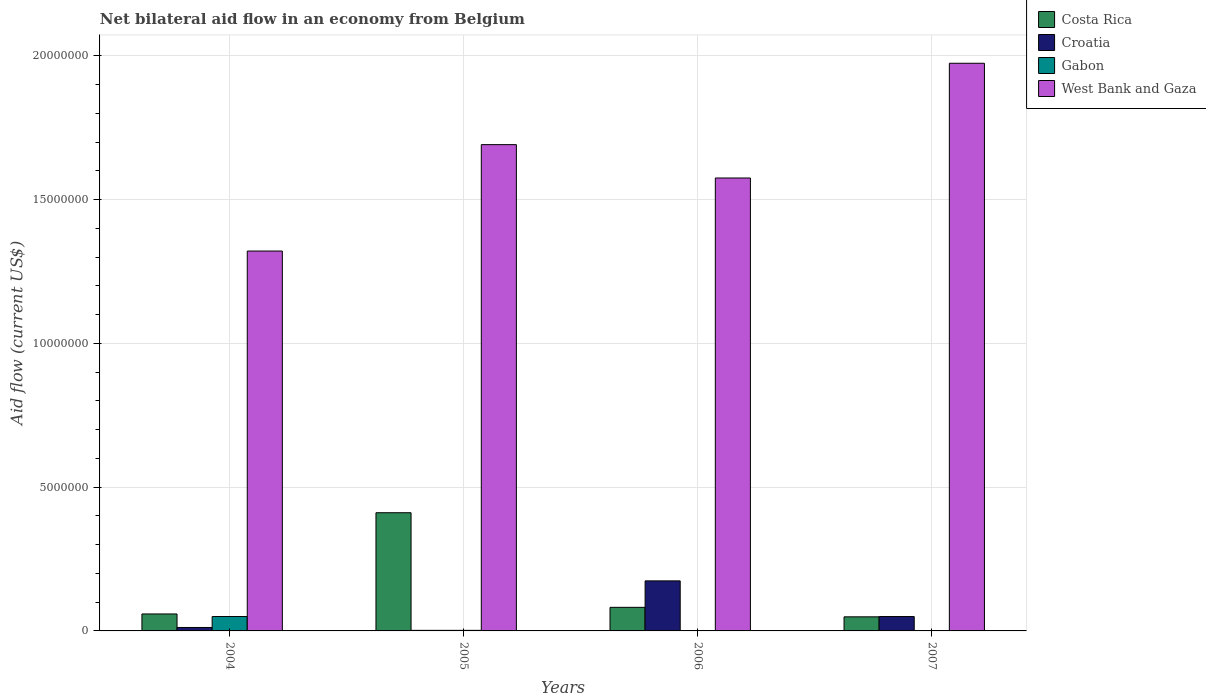How many groups of bars are there?
Your answer should be compact. 4. How many bars are there on the 2nd tick from the right?
Provide a short and direct response. 3. In how many cases, is the number of bars for a given year not equal to the number of legend labels?
Offer a very short reply. 2. What is the net bilateral aid flow in Costa Rica in 2006?
Ensure brevity in your answer.  8.20e+05. Across all years, what is the maximum net bilateral aid flow in West Bank and Gaza?
Make the answer very short. 1.97e+07. Across all years, what is the minimum net bilateral aid flow in Costa Rica?
Ensure brevity in your answer.  4.90e+05. In which year was the net bilateral aid flow in Croatia maximum?
Make the answer very short. 2006. What is the total net bilateral aid flow in Costa Rica in the graph?
Your answer should be very brief. 6.01e+06. What is the difference between the net bilateral aid flow in Croatia in 2007 and the net bilateral aid flow in West Bank and Gaza in 2006?
Make the answer very short. -1.52e+07. What is the average net bilateral aid flow in West Bank and Gaza per year?
Provide a short and direct response. 1.64e+07. In the year 2007, what is the difference between the net bilateral aid flow in Costa Rica and net bilateral aid flow in West Bank and Gaza?
Make the answer very short. -1.92e+07. In how many years, is the net bilateral aid flow in Croatia greater than 17000000 US$?
Your response must be concise. 0. What is the ratio of the net bilateral aid flow in Croatia in 2006 to that in 2007?
Offer a very short reply. 3.48. Is the net bilateral aid flow in Costa Rica in 2004 less than that in 2007?
Your response must be concise. No. Is the difference between the net bilateral aid flow in Costa Rica in 2005 and 2006 greater than the difference between the net bilateral aid flow in West Bank and Gaza in 2005 and 2006?
Make the answer very short. Yes. What is the difference between the highest and the second highest net bilateral aid flow in Costa Rica?
Your response must be concise. 3.29e+06. What is the difference between the highest and the lowest net bilateral aid flow in Croatia?
Your answer should be very brief. 1.72e+06. In how many years, is the net bilateral aid flow in West Bank and Gaza greater than the average net bilateral aid flow in West Bank and Gaza taken over all years?
Ensure brevity in your answer.  2. Is it the case that in every year, the sum of the net bilateral aid flow in Gabon and net bilateral aid flow in Croatia is greater than the sum of net bilateral aid flow in Costa Rica and net bilateral aid flow in West Bank and Gaza?
Provide a succinct answer. No. Is it the case that in every year, the sum of the net bilateral aid flow in West Bank and Gaza and net bilateral aid flow in Croatia is greater than the net bilateral aid flow in Costa Rica?
Provide a short and direct response. Yes. Are all the bars in the graph horizontal?
Provide a succinct answer. No. How many years are there in the graph?
Your answer should be compact. 4. What is the difference between two consecutive major ticks on the Y-axis?
Offer a terse response. 5.00e+06. Are the values on the major ticks of Y-axis written in scientific E-notation?
Offer a terse response. No. How are the legend labels stacked?
Your answer should be very brief. Vertical. What is the title of the graph?
Offer a terse response. Net bilateral aid flow in an economy from Belgium. Does "Croatia" appear as one of the legend labels in the graph?
Offer a very short reply. Yes. What is the Aid flow (current US$) in Costa Rica in 2004?
Ensure brevity in your answer.  5.90e+05. What is the Aid flow (current US$) of Croatia in 2004?
Provide a succinct answer. 1.20e+05. What is the Aid flow (current US$) of Gabon in 2004?
Give a very brief answer. 5.00e+05. What is the Aid flow (current US$) in West Bank and Gaza in 2004?
Ensure brevity in your answer.  1.32e+07. What is the Aid flow (current US$) in Costa Rica in 2005?
Give a very brief answer. 4.11e+06. What is the Aid flow (current US$) in West Bank and Gaza in 2005?
Give a very brief answer. 1.69e+07. What is the Aid flow (current US$) in Costa Rica in 2006?
Ensure brevity in your answer.  8.20e+05. What is the Aid flow (current US$) of Croatia in 2006?
Provide a short and direct response. 1.74e+06. What is the Aid flow (current US$) of West Bank and Gaza in 2006?
Give a very brief answer. 1.58e+07. What is the Aid flow (current US$) in West Bank and Gaza in 2007?
Your response must be concise. 1.97e+07. Across all years, what is the maximum Aid flow (current US$) in Costa Rica?
Offer a very short reply. 4.11e+06. Across all years, what is the maximum Aid flow (current US$) in Croatia?
Provide a succinct answer. 1.74e+06. Across all years, what is the maximum Aid flow (current US$) in West Bank and Gaza?
Your response must be concise. 1.97e+07. Across all years, what is the minimum Aid flow (current US$) in West Bank and Gaza?
Offer a very short reply. 1.32e+07. What is the total Aid flow (current US$) of Costa Rica in the graph?
Provide a short and direct response. 6.01e+06. What is the total Aid flow (current US$) in Croatia in the graph?
Your answer should be compact. 2.38e+06. What is the total Aid flow (current US$) of Gabon in the graph?
Provide a short and direct response. 5.20e+05. What is the total Aid flow (current US$) of West Bank and Gaza in the graph?
Your response must be concise. 6.56e+07. What is the difference between the Aid flow (current US$) of Costa Rica in 2004 and that in 2005?
Keep it short and to the point. -3.52e+06. What is the difference between the Aid flow (current US$) in Gabon in 2004 and that in 2005?
Keep it short and to the point. 4.80e+05. What is the difference between the Aid flow (current US$) in West Bank and Gaza in 2004 and that in 2005?
Give a very brief answer. -3.70e+06. What is the difference between the Aid flow (current US$) in Croatia in 2004 and that in 2006?
Provide a succinct answer. -1.62e+06. What is the difference between the Aid flow (current US$) in West Bank and Gaza in 2004 and that in 2006?
Provide a succinct answer. -2.54e+06. What is the difference between the Aid flow (current US$) in Croatia in 2004 and that in 2007?
Provide a short and direct response. -3.80e+05. What is the difference between the Aid flow (current US$) in West Bank and Gaza in 2004 and that in 2007?
Offer a terse response. -6.53e+06. What is the difference between the Aid flow (current US$) of Costa Rica in 2005 and that in 2006?
Ensure brevity in your answer.  3.29e+06. What is the difference between the Aid flow (current US$) of Croatia in 2005 and that in 2006?
Make the answer very short. -1.72e+06. What is the difference between the Aid flow (current US$) in West Bank and Gaza in 2005 and that in 2006?
Provide a short and direct response. 1.16e+06. What is the difference between the Aid flow (current US$) in Costa Rica in 2005 and that in 2007?
Offer a very short reply. 3.62e+06. What is the difference between the Aid flow (current US$) of Croatia in 2005 and that in 2007?
Your answer should be very brief. -4.80e+05. What is the difference between the Aid flow (current US$) of West Bank and Gaza in 2005 and that in 2007?
Give a very brief answer. -2.83e+06. What is the difference between the Aid flow (current US$) of Costa Rica in 2006 and that in 2007?
Your answer should be compact. 3.30e+05. What is the difference between the Aid flow (current US$) in Croatia in 2006 and that in 2007?
Your response must be concise. 1.24e+06. What is the difference between the Aid flow (current US$) of West Bank and Gaza in 2006 and that in 2007?
Make the answer very short. -3.99e+06. What is the difference between the Aid flow (current US$) in Costa Rica in 2004 and the Aid flow (current US$) in Croatia in 2005?
Offer a very short reply. 5.70e+05. What is the difference between the Aid flow (current US$) of Costa Rica in 2004 and the Aid flow (current US$) of Gabon in 2005?
Your answer should be very brief. 5.70e+05. What is the difference between the Aid flow (current US$) in Costa Rica in 2004 and the Aid flow (current US$) in West Bank and Gaza in 2005?
Your answer should be compact. -1.63e+07. What is the difference between the Aid flow (current US$) of Croatia in 2004 and the Aid flow (current US$) of Gabon in 2005?
Your answer should be compact. 1.00e+05. What is the difference between the Aid flow (current US$) of Croatia in 2004 and the Aid flow (current US$) of West Bank and Gaza in 2005?
Provide a short and direct response. -1.68e+07. What is the difference between the Aid flow (current US$) of Gabon in 2004 and the Aid flow (current US$) of West Bank and Gaza in 2005?
Offer a very short reply. -1.64e+07. What is the difference between the Aid flow (current US$) of Costa Rica in 2004 and the Aid flow (current US$) of Croatia in 2006?
Make the answer very short. -1.15e+06. What is the difference between the Aid flow (current US$) of Costa Rica in 2004 and the Aid flow (current US$) of West Bank and Gaza in 2006?
Your answer should be very brief. -1.52e+07. What is the difference between the Aid flow (current US$) in Croatia in 2004 and the Aid flow (current US$) in West Bank and Gaza in 2006?
Ensure brevity in your answer.  -1.56e+07. What is the difference between the Aid flow (current US$) in Gabon in 2004 and the Aid flow (current US$) in West Bank and Gaza in 2006?
Give a very brief answer. -1.52e+07. What is the difference between the Aid flow (current US$) in Costa Rica in 2004 and the Aid flow (current US$) in Croatia in 2007?
Make the answer very short. 9.00e+04. What is the difference between the Aid flow (current US$) in Costa Rica in 2004 and the Aid flow (current US$) in West Bank and Gaza in 2007?
Your answer should be very brief. -1.92e+07. What is the difference between the Aid flow (current US$) in Croatia in 2004 and the Aid flow (current US$) in West Bank and Gaza in 2007?
Offer a very short reply. -1.96e+07. What is the difference between the Aid flow (current US$) in Gabon in 2004 and the Aid flow (current US$) in West Bank and Gaza in 2007?
Provide a short and direct response. -1.92e+07. What is the difference between the Aid flow (current US$) in Costa Rica in 2005 and the Aid flow (current US$) in Croatia in 2006?
Keep it short and to the point. 2.37e+06. What is the difference between the Aid flow (current US$) of Costa Rica in 2005 and the Aid flow (current US$) of West Bank and Gaza in 2006?
Make the answer very short. -1.16e+07. What is the difference between the Aid flow (current US$) of Croatia in 2005 and the Aid flow (current US$) of West Bank and Gaza in 2006?
Your answer should be compact. -1.57e+07. What is the difference between the Aid flow (current US$) of Gabon in 2005 and the Aid flow (current US$) of West Bank and Gaza in 2006?
Make the answer very short. -1.57e+07. What is the difference between the Aid flow (current US$) in Costa Rica in 2005 and the Aid flow (current US$) in Croatia in 2007?
Your answer should be very brief. 3.61e+06. What is the difference between the Aid flow (current US$) in Costa Rica in 2005 and the Aid flow (current US$) in West Bank and Gaza in 2007?
Provide a short and direct response. -1.56e+07. What is the difference between the Aid flow (current US$) in Croatia in 2005 and the Aid flow (current US$) in West Bank and Gaza in 2007?
Your answer should be compact. -1.97e+07. What is the difference between the Aid flow (current US$) of Gabon in 2005 and the Aid flow (current US$) of West Bank and Gaza in 2007?
Offer a very short reply. -1.97e+07. What is the difference between the Aid flow (current US$) in Costa Rica in 2006 and the Aid flow (current US$) in West Bank and Gaza in 2007?
Provide a short and direct response. -1.89e+07. What is the difference between the Aid flow (current US$) in Croatia in 2006 and the Aid flow (current US$) in West Bank and Gaza in 2007?
Your answer should be very brief. -1.80e+07. What is the average Aid flow (current US$) in Costa Rica per year?
Provide a succinct answer. 1.50e+06. What is the average Aid flow (current US$) of Croatia per year?
Give a very brief answer. 5.95e+05. What is the average Aid flow (current US$) of West Bank and Gaza per year?
Keep it short and to the point. 1.64e+07. In the year 2004, what is the difference between the Aid flow (current US$) of Costa Rica and Aid flow (current US$) of Gabon?
Offer a very short reply. 9.00e+04. In the year 2004, what is the difference between the Aid flow (current US$) of Costa Rica and Aid flow (current US$) of West Bank and Gaza?
Provide a short and direct response. -1.26e+07. In the year 2004, what is the difference between the Aid flow (current US$) in Croatia and Aid flow (current US$) in Gabon?
Offer a terse response. -3.80e+05. In the year 2004, what is the difference between the Aid flow (current US$) of Croatia and Aid flow (current US$) of West Bank and Gaza?
Give a very brief answer. -1.31e+07. In the year 2004, what is the difference between the Aid flow (current US$) in Gabon and Aid flow (current US$) in West Bank and Gaza?
Ensure brevity in your answer.  -1.27e+07. In the year 2005, what is the difference between the Aid flow (current US$) of Costa Rica and Aid flow (current US$) of Croatia?
Offer a terse response. 4.09e+06. In the year 2005, what is the difference between the Aid flow (current US$) of Costa Rica and Aid flow (current US$) of Gabon?
Your answer should be compact. 4.09e+06. In the year 2005, what is the difference between the Aid flow (current US$) of Costa Rica and Aid flow (current US$) of West Bank and Gaza?
Your response must be concise. -1.28e+07. In the year 2005, what is the difference between the Aid flow (current US$) in Croatia and Aid flow (current US$) in West Bank and Gaza?
Your answer should be compact. -1.69e+07. In the year 2005, what is the difference between the Aid flow (current US$) of Gabon and Aid flow (current US$) of West Bank and Gaza?
Provide a short and direct response. -1.69e+07. In the year 2006, what is the difference between the Aid flow (current US$) of Costa Rica and Aid flow (current US$) of Croatia?
Offer a terse response. -9.20e+05. In the year 2006, what is the difference between the Aid flow (current US$) in Costa Rica and Aid flow (current US$) in West Bank and Gaza?
Make the answer very short. -1.49e+07. In the year 2006, what is the difference between the Aid flow (current US$) of Croatia and Aid flow (current US$) of West Bank and Gaza?
Provide a short and direct response. -1.40e+07. In the year 2007, what is the difference between the Aid flow (current US$) of Costa Rica and Aid flow (current US$) of West Bank and Gaza?
Keep it short and to the point. -1.92e+07. In the year 2007, what is the difference between the Aid flow (current US$) in Croatia and Aid flow (current US$) in West Bank and Gaza?
Provide a short and direct response. -1.92e+07. What is the ratio of the Aid flow (current US$) in Costa Rica in 2004 to that in 2005?
Your answer should be very brief. 0.14. What is the ratio of the Aid flow (current US$) in Croatia in 2004 to that in 2005?
Your response must be concise. 6. What is the ratio of the Aid flow (current US$) in West Bank and Gaza in 2004 to that in 2005?
Offer a terse response. 0.78. What is the ratio of the Aid flow (current US$) in Costa Rica in 2004 to that in 2006?
Give a very brief answer. 0.72. What is the ratio of the Aid flow (current US$) in Croatia in 2004 to that in 2006?
Provide a succinct answer. 0.07. What is the ratio of the Aid flow (current US$) of West Bank and Gaza in 2004 to that in 2006?
Provide a short and direct response. 0.84. What is the ratio of the Aid flow (current US$) of Costa Rica in 2004 to that in 2007?
Your answer should be compact. 1.2. What is the ratio of the Aid flow (current US$) in Croatia in 2004 to that in 2007?
Offer a terse response. 0.24. What is the ratio of the Aid flow (current US$) in West Bank and Gaza in 2004 to that in 2007?
Give a very brief answer. 0.67. What is the ratio of the Aid flow (current US$) of Costa Rica in 2005 to that in 2006?
Provide a succinct answer. 5.01. What is the ratio of the Aid flow (current US$) of Croatia in 2005 to that in 2006?
Offer a very short reply. 0.01. What is the ratio of the Aid flow (current US$) in West Bank and Gaza in 2005 to that in 2006?
Make the answer very short. 1.07. What is the ratio of the Aid flow (current US$) in Costa Rica in 2005 to that in 2007?
Ensure brevity in your answer.  8.39. What is the ratio of the Aid flow (current US$) of Croatia in 2005 to that in 2007?
Provide a succinct answer. 0.04. What is the ratio of the Aid flow (current US$) of West Bank and Gaza in 2005 to that in 2007?
Provide a short and direct response. 0.86. What is the ratio of the Aid flow (current US$) in Costa Rica in 2006 to that in 2007?
Your response must be concise. 1.67. What is the ratio of the Aid flow (current US$) of Croatia in 2006 to that in 2007?
Your answer should be compact. 3.48. What is the ratio of the Aid flow (current US$) in West Bank and Gaza in 2006 to that in 2007?
Give a very brief answer. 0.8. What is the difference between the highest and the second highest Aid flow (current US$) of Costa Rica?
Your response must be concise. 3.29e+06. What is the difference between the highest and the second highest Aid flow (current US$) of Croatia?
Keep it short and to the point. 1.24e+06. What is the difference between the highest and the second highest Aid flow (current US$) in West Bank and Gaza?
Provide a short and direct response. 2.83e+06. What is the difference between the highest and the lowest Aid flow (current US$) in Costa Rica?
Your answer should be compact. 3.62e+06. What is the difference between the highest and the lowest Aid flow (current US$) of Croatia?
Make the answer very short. 1.72e+06. What is the difference between the highest and the lowest Aid flow (current US$) of Gabon?
Your response must be concise. 5.00e+05. What is the difference between the highest and the lowest Aid flow (current US$) in West Bank and Gaza?
Ensure brevity in your answer.  6.53e+06. 